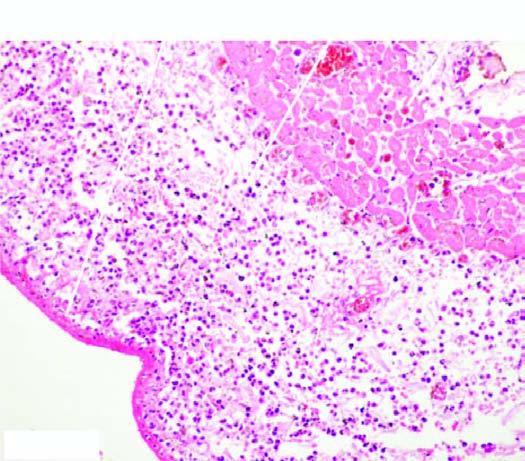what is covered with pink serofibrinous exudates?
Answer the question using a single word or phrase. The pericardium 